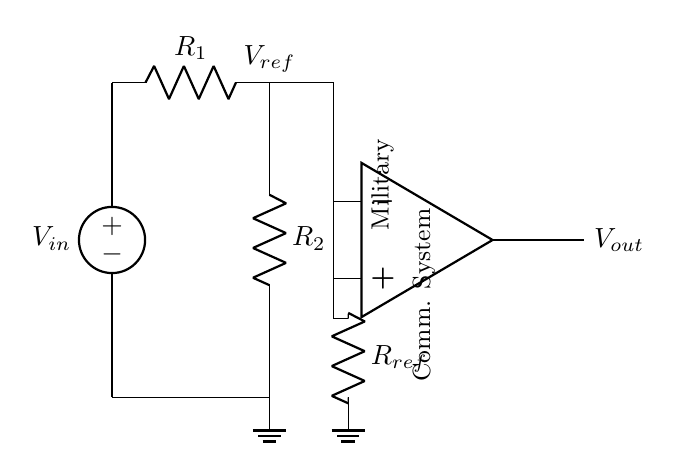What is the function of the op-amp in this circuit? The op-amp is used as a comparator to compare the input voltage with the reference voltage. It determines whether the input is higher or lower than the reference, thus controlling the output voltage accordingly.
Answer: Comparator What is the reference voltage represented by? The reference voltage is represented by the voltage across the resistor divider created by R1 and R2. It sets a threshold for the comparison with the input voltage.
Answer: V ref How many resistors are in the circuit? There are three resistors in the circuit: R1, R2, and Rref. Each one plays a role in determining voltage levels within the circuit.
Answer: Three What is the purpose of the resistor Rref? Rref sets the reference voltage for the op-amp comparator and helps ensure that the op-amp compares the input voltage against a stable voltage level.
Answer: Set reference voltage What happens to Vout if Vin exceeds Vref? If Vin exceeds Vref, Vout will switch to a high state, typically close to the positive supply voltage of the op-amp, indicating a positive comparison.
Answer: High state What type of circuit is this? This is an analog comparator circuit, which is designed to detect the relationship between two voltage levels for decision-making.
Answer: Analog comparator What does the ground symbol indicate in this circuit? The ground symbol indicates a common reference point for the voltages in the circuit, establishing a zero voltage level from which all other voltages are measured.
Answer: Common reference point 